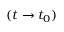Convert formula to latex. <formula><loc_0><loc_0><loc_500><loc_500>( t \rightarrow t _ { 0 } )</formula> 